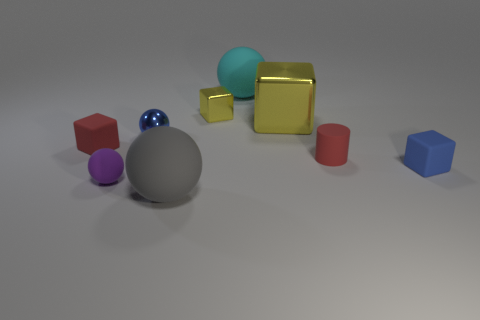Add 1 big gray metallic blocks. How many objects exist? 10 Subtract all cubes. How many objects are left? 5 Subtract all yellow blocks. Subtract all small rubber spheres. How many objects are left? 6 Add 4 yellow blocks. How many yellow blocks are left? 6 Add 1 blue rubber things. How many blue rubber things exist? 2 Subtract 0 purple cylinders. How many objects are left? 9 